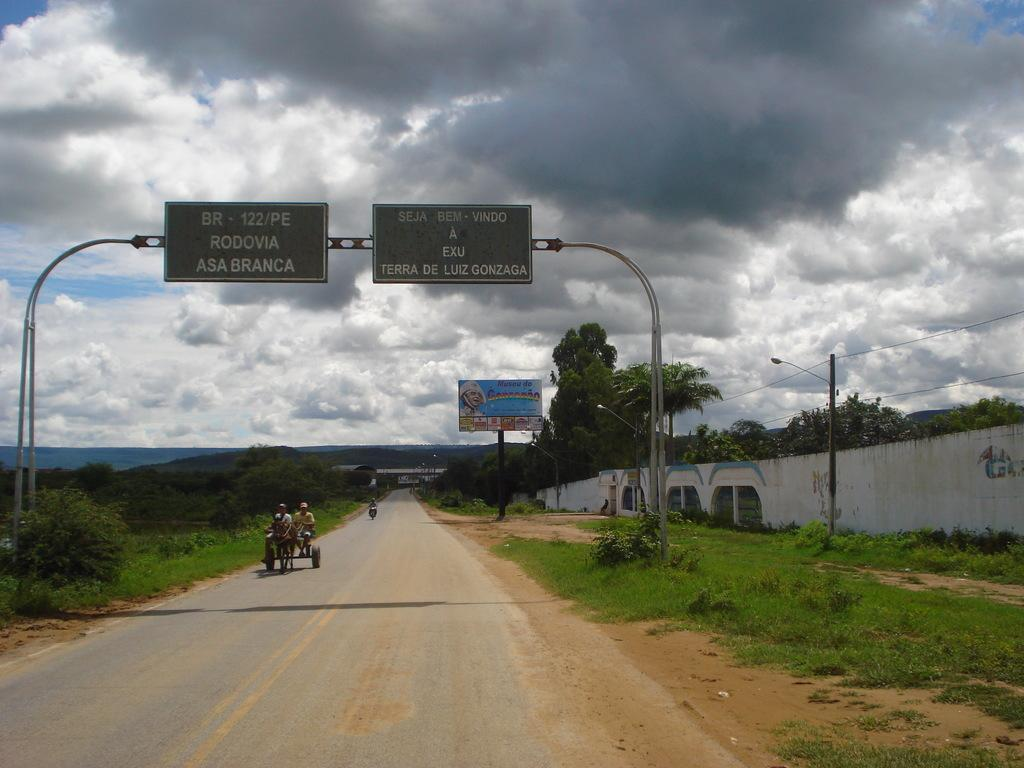Provide a one-sentence caption for the provided image. People travel by horse drawn carriage down BR- 122/PE. 